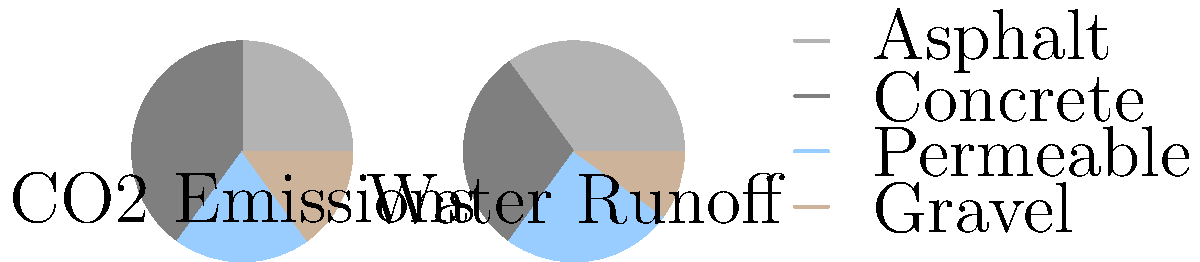Based on the pie charts showing CO2 emissions and water runoff for different road surface materials, which material appears to be the most environmentally friendly option for a new local road project, considering both factors equally? To determine the most environmentally friendly road surface material, we need to consider both CO2 emissions and water runoff:

1. Asphalt:
   - CO2 emissions: 25%
   - Water runoff: 35%
   - Total impact: 60%

2. Concrete:
   - CO2 emissions: 40%
   - Water runoff: 30%
   - Total impact: 70%

3. Permeable:
   - CO2 emissions: 20%
   - Water runoff: 25%
   - Total impact: 45%

4. Gravel:
   - CO2 emissions: 15%
   - Water runoff: 10%
   - Total impact: 25%

Comparing the total impact percentages, we can see that gravel has the lowest combined impact (25%), followed by permeable surfaces (45%), asphalt (60%), and concrete (70%).

However, as an environmentalist, we should also consider the practicality and long-term sustainability of each option. While gravel has the lowest immediate impact, it may require more frequent maintenance and replacement, potentially increasing its long-term environmental impact.

Permeable surfaces, despite having a slightly higher impact than gravel, offer a good balance between environmental friendliness and practicality. They allow water to filter through, reducing runoff and helping to recharge groundwater, which is an important ecological consideration.
Answer: Permeable surfaces 